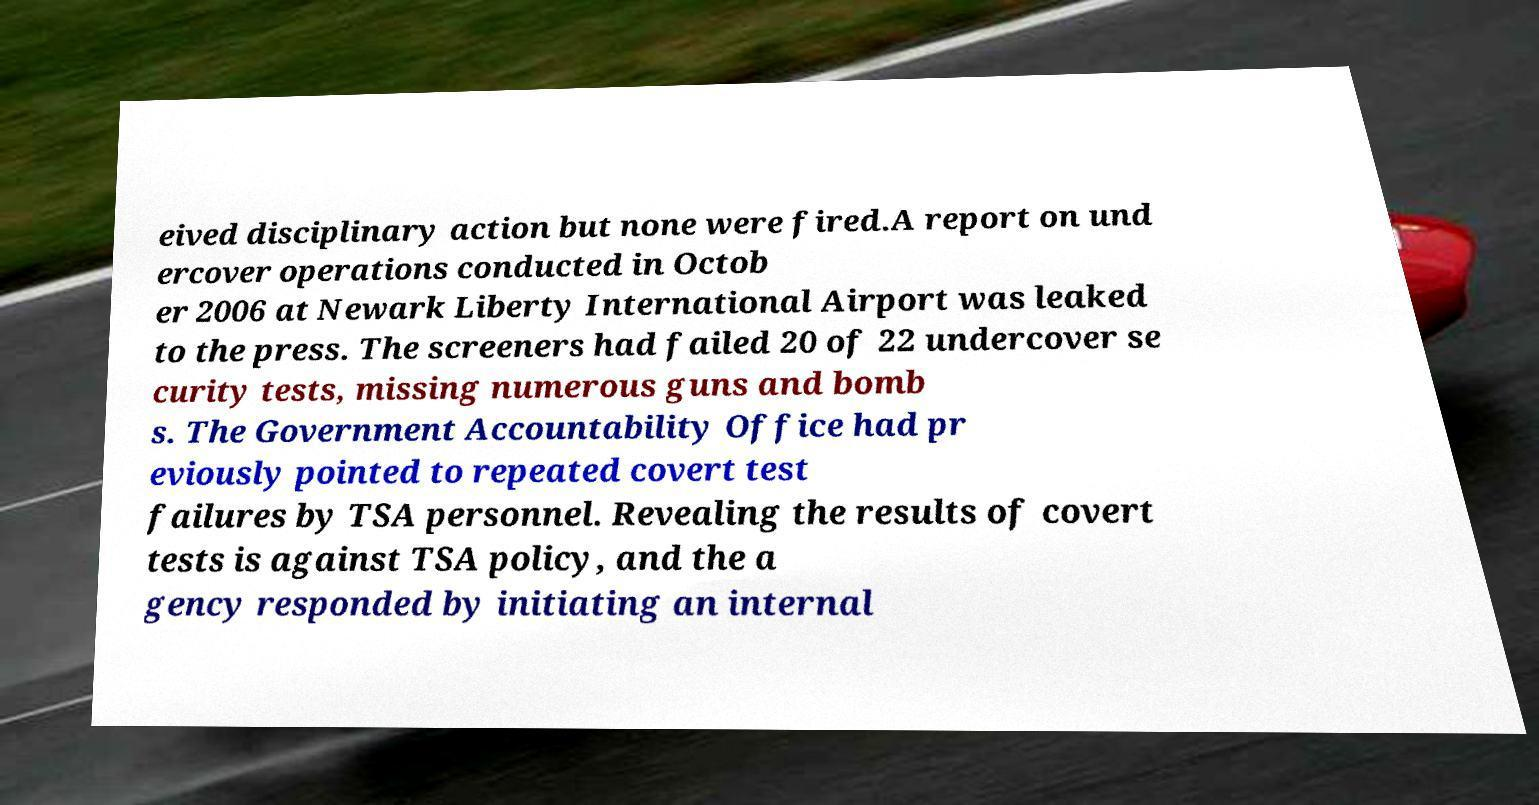Can you accurately transcribe the text from the provided image for me? eived disciplinary action but none were fired.A report on und ercover operations conducted in Octob er 2006 at Newark Liberty International Airport was leaked to the press. The screeners had failed 20 of 22 undercover se curity tests, missing numerous guns and bomb s. The Government Accountability Office had pr eviously pointed to repeated covert test failures by TSA personnel. Revealing the results of covert tests is against TSA policy, and the a gency responded by initiating an internal 